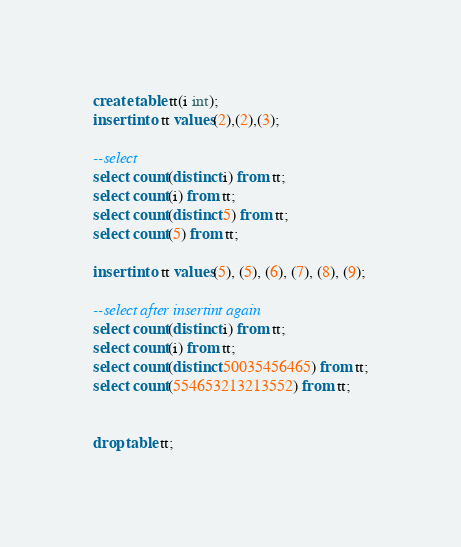Convert code to text. <code><loc_0><loc_0><loc_500><loc_500><_SQL_>create table tt(i int);
insert into tt values(2),(2),(3);

--select
select count(distinct i) from tt;
select count(i) from tt;
select count(distinct 5) from tt;
select count(5) from tt;

insert into tt values(5), (5), (6), (7), (8), (9);

--select after insertint again
select count(distinct i) from tt;
select count(i) from tt;
select count(distinct 50035456465) from tt;
select count(554653213213552) from tt;


drop table tt;
</code> 